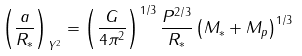<formula> <loc_0><loc_0><loc_500><loc_500>\left ( \frac { a } { R _ { * } } \right ) _ { Y ^ { 2 } } = \left ( \frac { G } { 4 \pi ^ { 2 } } \right ) ^ { 1 / 3 } \frac { P ^ { 2 / 3 } } { R _ { * } } \left ( M _ { * } + M _ { p } \right ) ^ { 1 / 3 }</formula> 